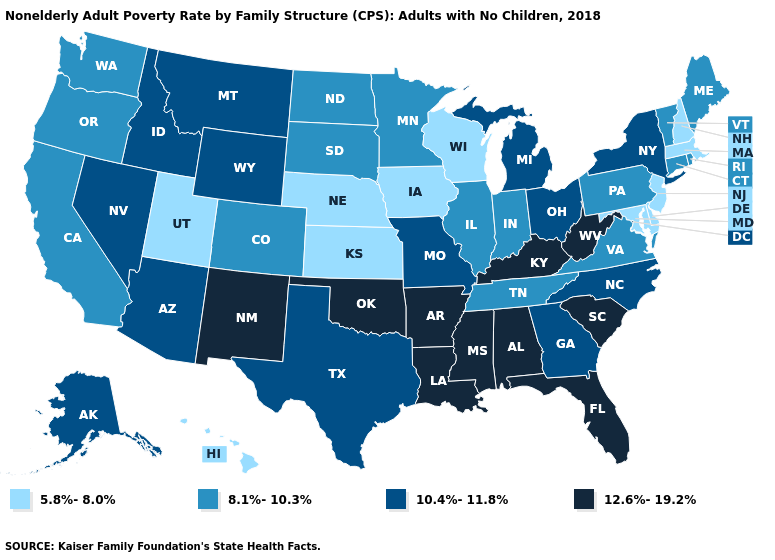What is the value of Florida?
Concise answer only. 12.6%-19.2%. What is the highest value in states that border Rhode Island?
Write a very short answer. 8.1%-10.3%. What is the value of Pennsylvania?
Be succinct. 8.1%-10.3%. Is the legend a continuous bar?
Be succinct. No. What is the lowest value in the USA?
Be succinct. 5.8%-8.0%. What is the value of Maine?
Quick response, please. 8.1%-10.3%. What is the highest value in the West ?
Short answer required. 12.6%-19.2%. Name the states that have a value in the range 5.8%-8.0%?
Be succinct. Delaware, Hawaii, Iowa, Kansas, Maryland, Massachusetts, Nebraska, New Hampshire, New Jersey, Utah, Wisconsin. What is the value of Arkansas?
Quick response, please. 12.6%-19.2%. Name the states that have a value in the range 8.1%-10.3%?
Write a very short answer. California, Colorado, Connecticut, Illinois, Indiana, Maine, Minnesota, North Dakota, Oregon, Pennsylvania, Rhode Island, South Dakota, Tennessee, Vermont, Virginia, Washington. Does the first symbol in the legend represent the smallest category?
Quick response, please. Yes. What is the value of New Jersey?
Short answer required. 5.8%-8.0%. What is the value of New Jersey?
Answer briefly. 5.8%-8.0%. What is the lowest value in states that border Maryland?
Concise answer only. 5.8%-8.0%. Name the states that have a value in the range 12.6%-19.2%?
Give a very brief answer. Alabama, Arkansas, Florida, Kentucky, Louisiana, Mississippi, New Mexico, Oklahoma, South Carolina, West Virginia. 